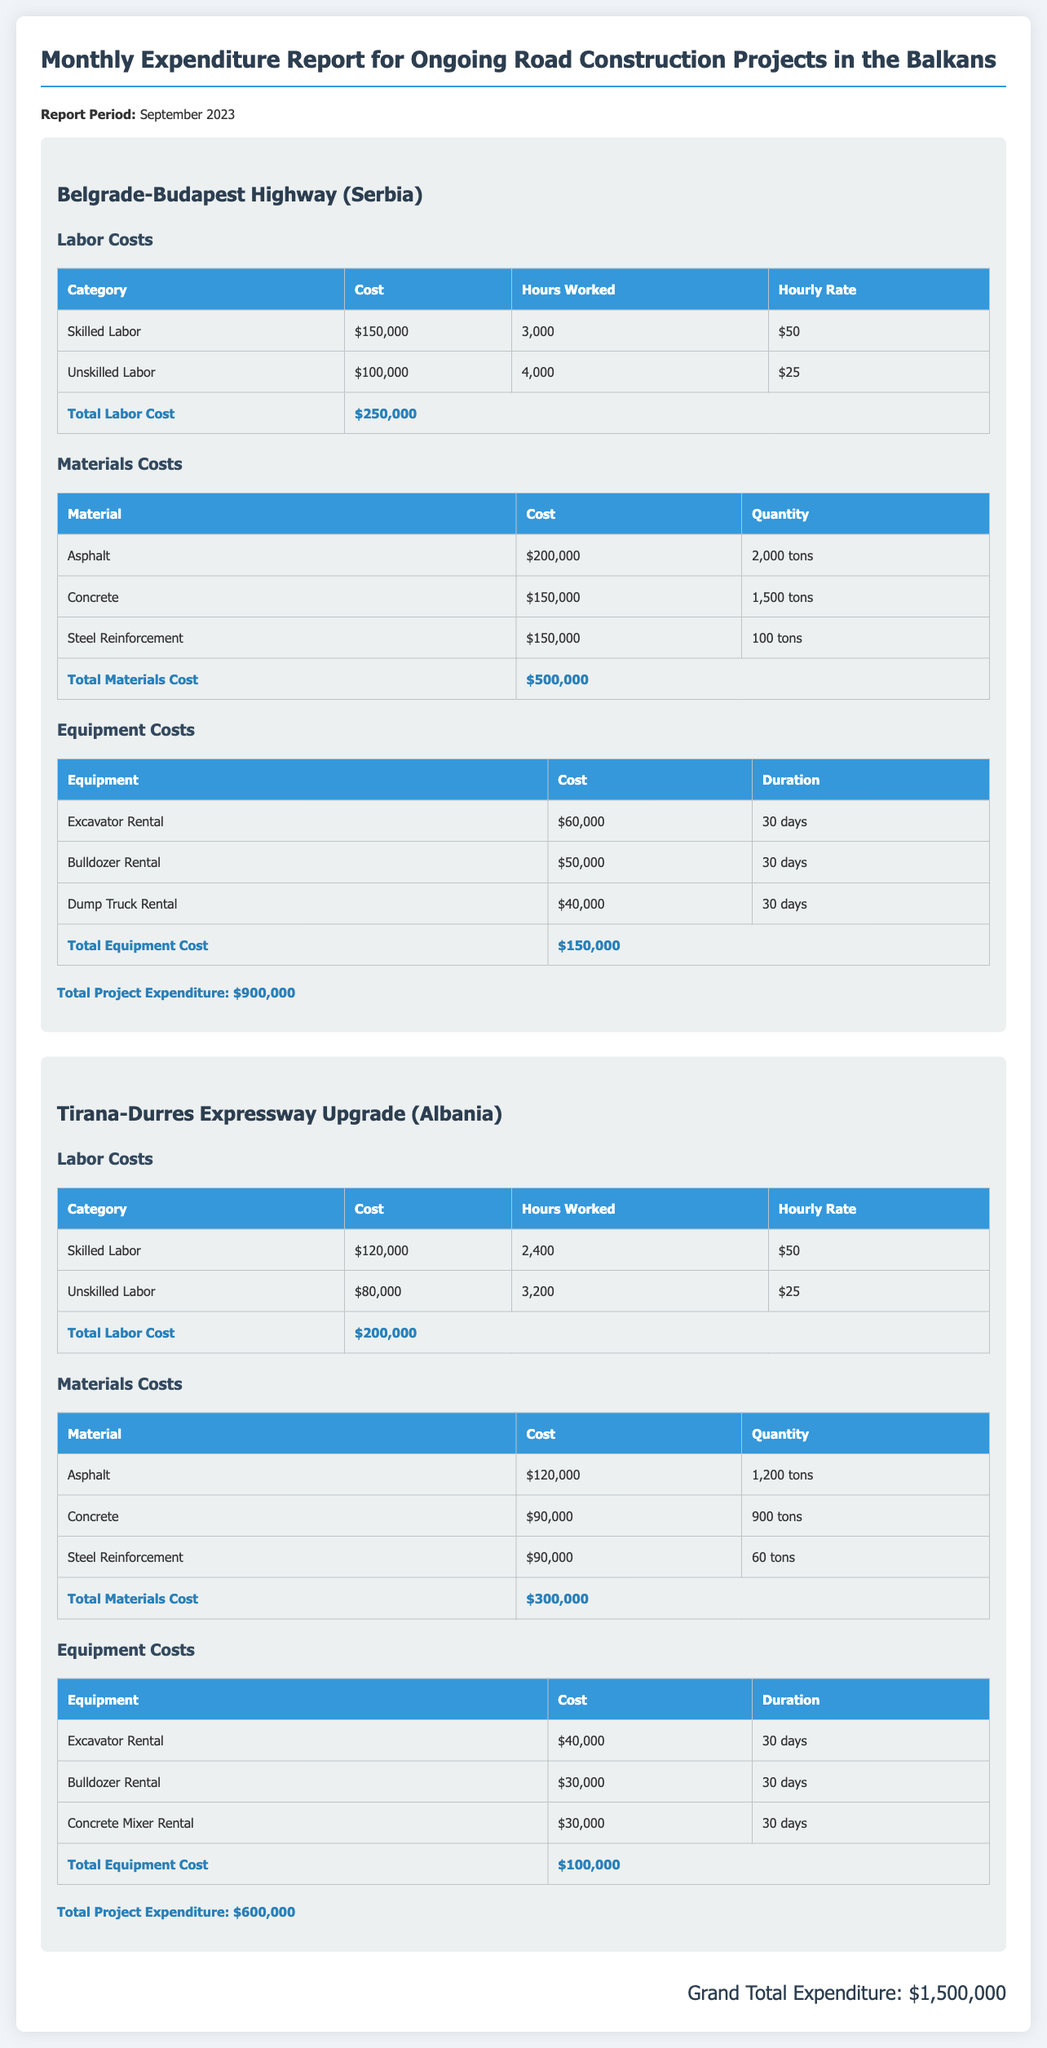What is the report period? The report period is stated at the beginning of the document.
Answer: September 2023 What is the total labor cost for the Belgrade-Budapest Highway project? The total labor cost for the project is found in the labor costs section of the report.
Answer: $250,000 How many tons of asphalt were purchased for the Tirana-Durres Expressway Upgrade? The quantity of asphalt is listed in the materials section for the Tirana-Durres Expressway Upgrade.
Answer: 1,200 tons What is the total project expenditure for the Tirana-Durres Expressway Upgrade? The total project expenditure is highlighted at the end of the respective project section.
Answer: $600,000 What is the grand total expenditure for all projects? The grand total expenditure is provided at the end of the document and combines all project expenditures.
Answer: $1,500,000 What equipment costs are associated with the Belgrade-Budapest Highway? The equipment costs detail the rental expenses for various equipment in the Highway section.
Answer: $150,000 How many hours were worked by unskilled labor on the Belgrade-Budapest Highway? The hours worked by unskilled labor are specifically mentioned in the labor costs table.
Answer: 4,000 How much was spent on steel reinforcement for the Tirana-Durres Expressway Upgrade? The cost of steel reinforcement is listed in the materials table for that project.
Answer: $90,000 